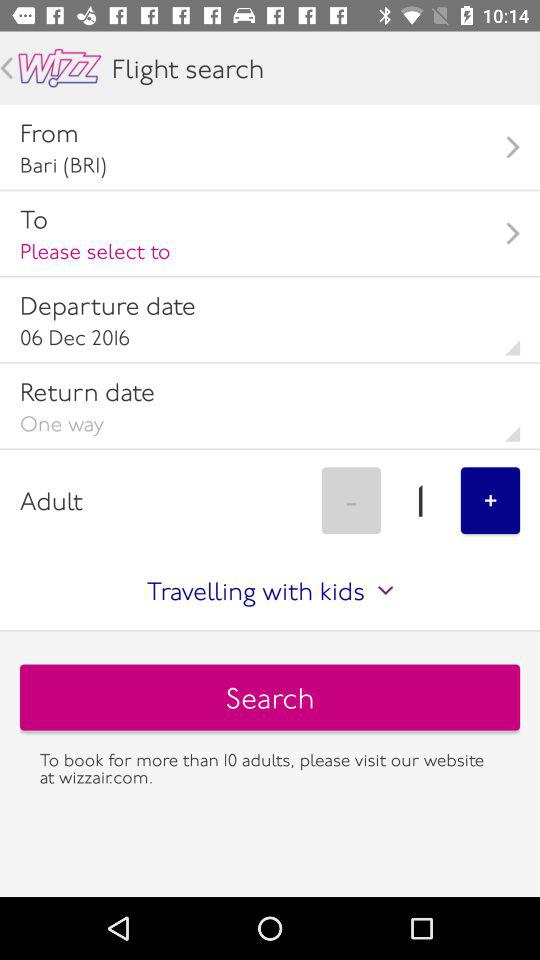How many adults are currently selected for the booking?
Answer the question using a single word or phrase. 1 